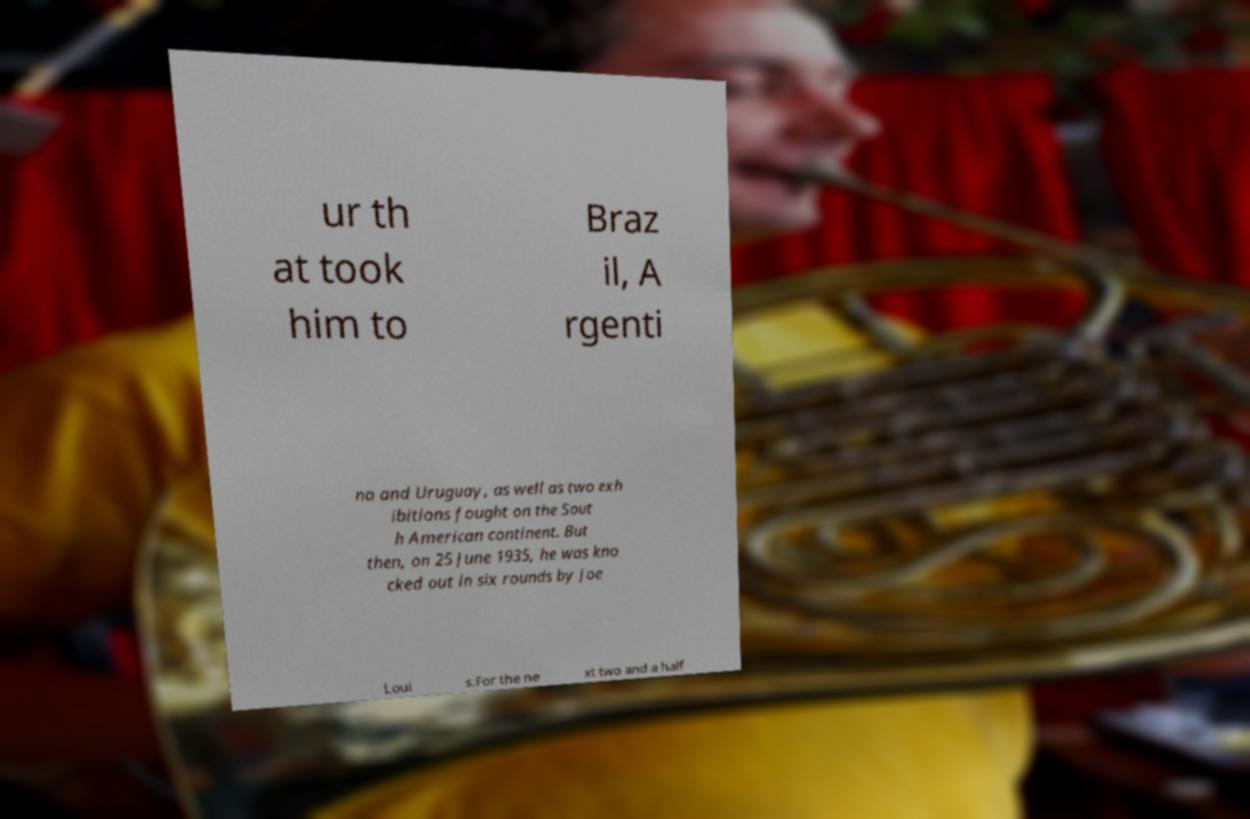What messages or text are displayed in this image? I need them in a readable, typed format. ur th at took him to Braz il, A rgenti na and Uruguay, as well as two exh ibitions fought on the Sout h American continent. But then, on 25 June 1935, he was kno cked out in six rounds by Joe Loui s.For the ne xt two and a half 